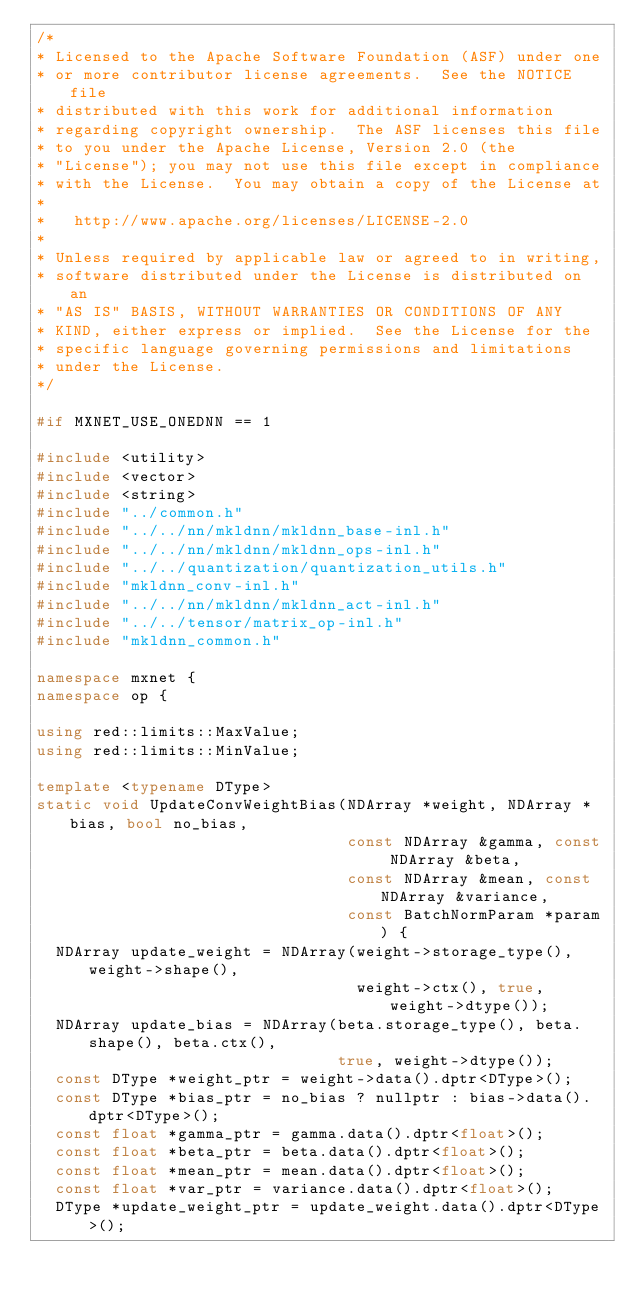<code> <loc_0><loc_0><loc_500><loc_500><_C++_>/*
* Licensed to the Apache Software Foundation (ASF) under one
* or more contributor license agreements.  See the NOTICE file
* distributed with this work for additional information
* regarding copyright ownership.  The ASF licenses this file
* to you under the Apache License, Version 2.0 (the
* "License"); you may not use this file except in compliance
* with the License.  You may obtain a copy of the License at
*
*   http://www.apache.org/licenses/LICENSE-2.0
*
* Unless required by applicable law or agreed to in writing,
* software distributed under the License is distributed on an
* "AS IS" BASIS, WITHOUT WARRANTIES OR CONDITIONS OF ANY
* KIND, either express or implied.  See the License for the
* specific language governing permissions and limitations
* under the License.
*/

#if MXNET_USE_ONEDNN == 1

#include <utility>
#include <vector>
#include <string>
#include "../common.h"
#include "../../nn/mkldnn/mkldnn_base-inl.h"
#include "../../nn/mkldnn/mkldnn_ops-inl.h"
#include "../../quantization/quantization_utils.h"
#include "mkldnn_conv-inl.h"
#include "../../nn/mkldnn/mkldnn_act-inl.h"
#include "../../tensor/matrix_op-inl.h"
#include "mkldnn_common.h"

namespace mxnet {
namespace op {

using red::limits::MaxValue;
using red::limits::MinValue;

template <typename DType>
static void UpdateConvWeightBias(NDArray *weight, NDArray *bias, bool no_bias,
                                 const NDArray &gamma, const NDArray &beta,
                                 const NDArray &mean, const NDArray &variance,
                                 const BatchNormParam *param) {
  NDArray update_weight = NDArray(weight->storage_type(), weight->shape(),
                                  weight->ctx(), true, weight->dtype());
  NDArray update_bias = NDArray(beta.storage_type(), beta.shape(), beta.ctx(),
                                true, weight->dtype());
  const DType *weight_ptr = weight->data().dptr<DType>();
  const DType *bias_ptr = no_bias ? nullptr : bias->data().dptr<DType>();
  const float *gamma_ptr = gamma.data().dptr<float>();
  const float *beta_ptr = beta.data().dptr<float>();
  const float *mean_ptr = mean.data().dptr<float>();
  const float *var_ptr = variance.data().dptr<float>();
  DType *update_weight_ptr = update_weight.data().dptr<DType>();</code> 